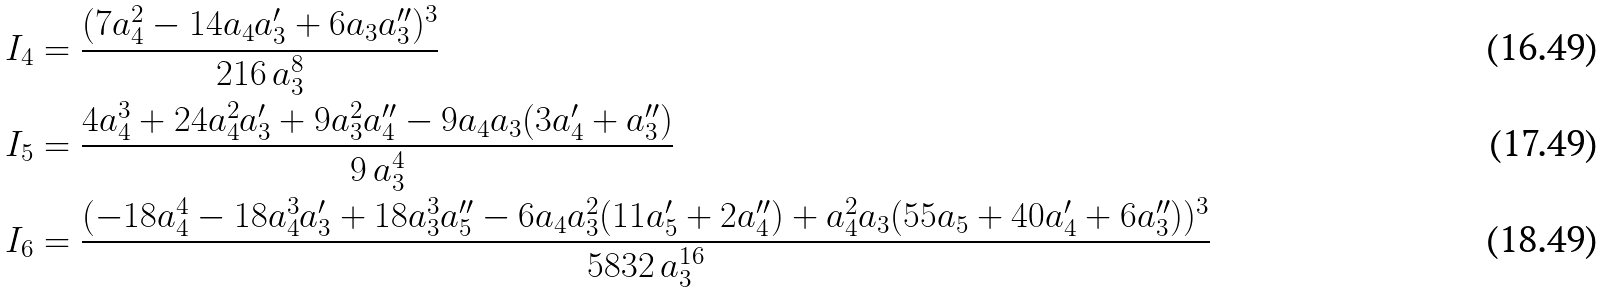<formula> <loc_0><loc_0><loc_500><loc_500>I _ { 4 } & = \frac { ( 7 a _ { 4 } ^ { 2 } - 1 4 a _ { 4 } a _ { 3 } ^ { \prime } + 6 a _ { 3 } a _ { 3 } ^ { \prime \prime } ) ^ { 3 } } { 2 1 6 \, a _ { 3 } ^ { 8 } } \\ I _ { 5 } & = \frac { 4 a _ { 4 } ^ { 3 } + 2 4 a _ { 4 } ^ { 2 } a _ { 3 } ^ { \prime } + 9 a _ { 3 } ^ { 2 } a _ { 4 } ^ { \prime \prime } - 9 a _ { 4 } a _ { 3 } ( 3 a _ { 4 } ^ { \prime } + a _ { 3 } ^ { \prime \prime } ) } { 9 \, a _ { 3 } ^ { 4 } } \\ I _ { 6 } & = \frac { ( - 1 8 a _ { 4 } ^ { 4 } - 1 8 a _ { 4 } ^ { 3 } a _ { 3 } ^ { \prime } + 1 8 a _ { 3 } ^ { 3 } a _ { 5 } ^ { \prime \prime } - 6 a _ { 4 } a _ { 3 } ^ { 2 } ( 1 1 a _ { 5 } ^ { \prime } + 2 a _ { 4 } ^ { \prime \prime } ) + a _ { 4 } ^ { 2 } a _ { 3 } ( 5 5 a _ { 5 } + 4 0 a _ { 4 } ^ { \prime } + 6 a _ { 3 } ^ { \prime \prime } ) ) ^ { 3 } } { 5 8 3 2 \, a _ { 3 } ^ { 1 6 } }</formula> 